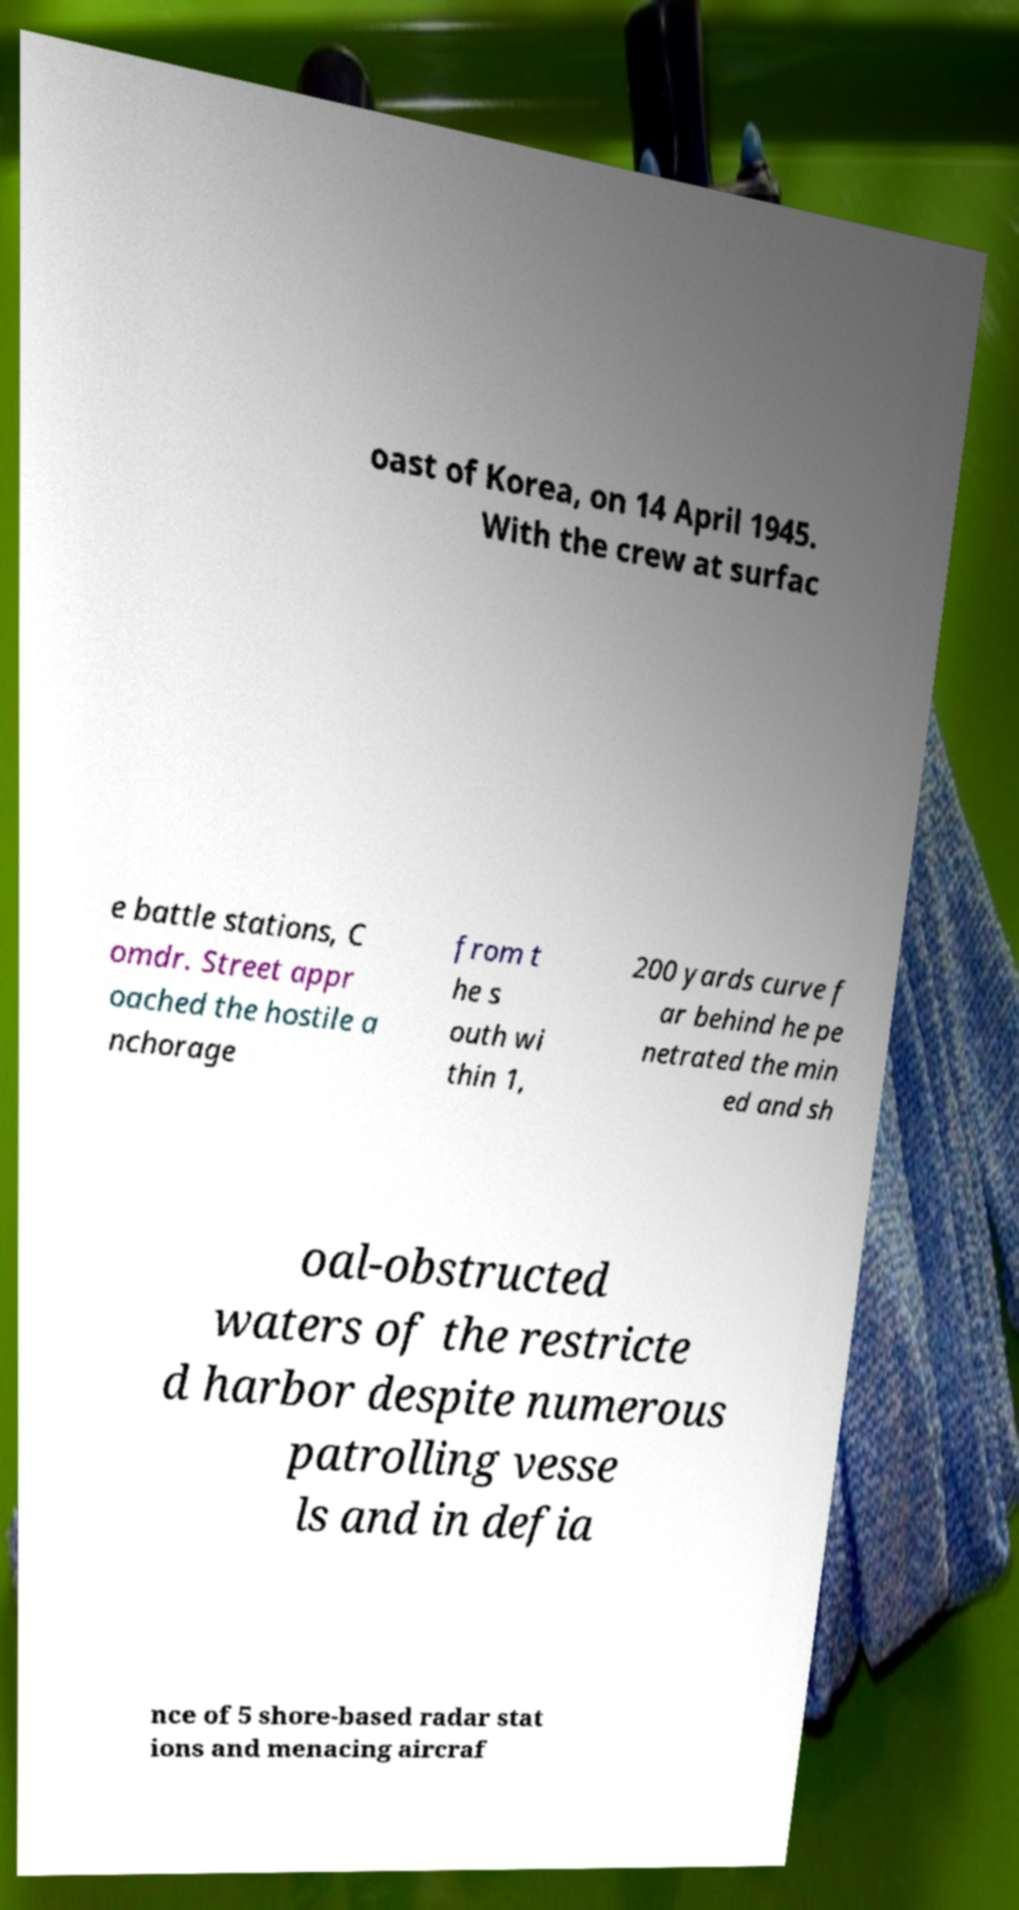Could you assist in decoding the text presented in this image and type it out clearly? oast of Korea, on 14 April 1945. With the crew at surfac e battle stations, C omdr. Street appr oached the hostile a nchorage from t he s outh wi thin 1, 200 yards curve f ar behind he pe netrated the min ed and sh oal-obstructed waters of the restricte d harbor despite numerous patrolling vesse ls and in defia nce of 5 shore-based radar stat ions and menacing aircraf 